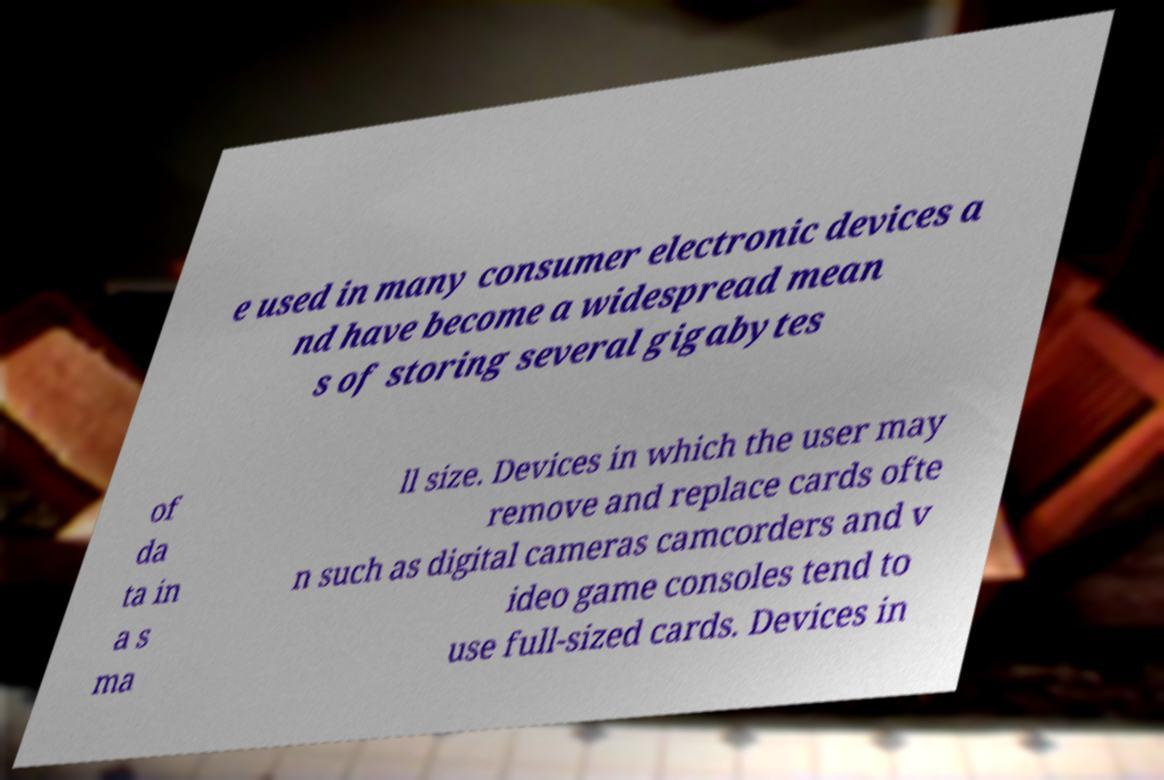Could you assist in decoding the text presented in this image and type it out clearly? e used in many consumer electronic devices a nd have become a widespread mean s of storing several gigabytes of da ta in a s ma ll size. Devices in which the user may remove and replace cards ofte n such as digital cameras camcorders and v ideo game consoles tend to use full-sized cards. Devices in 